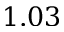<formula> <loc_0><loc_0><loc_500><loc_500>1 . 0 3</formula> 